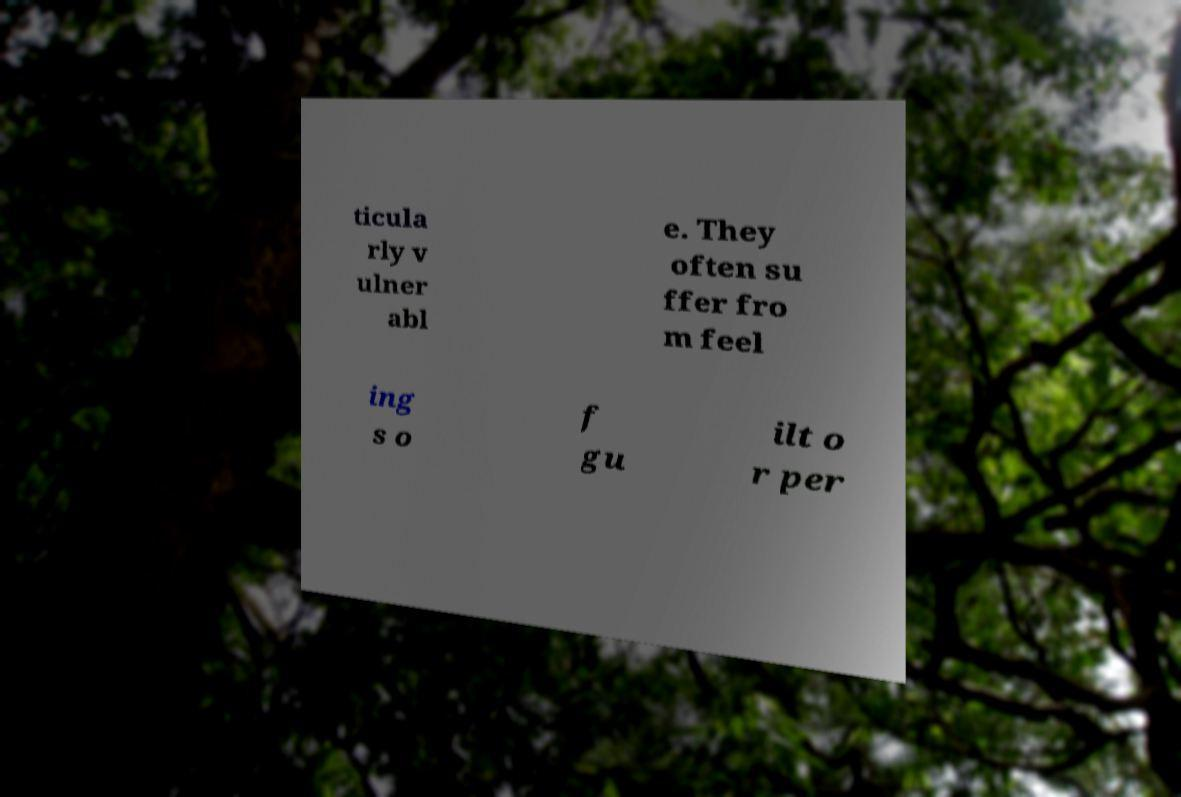Please identify and transcribe the text found in this image. ticula rly v ulner abl e. They often su ffer fro m feel ing s o f gu ilt o r per 